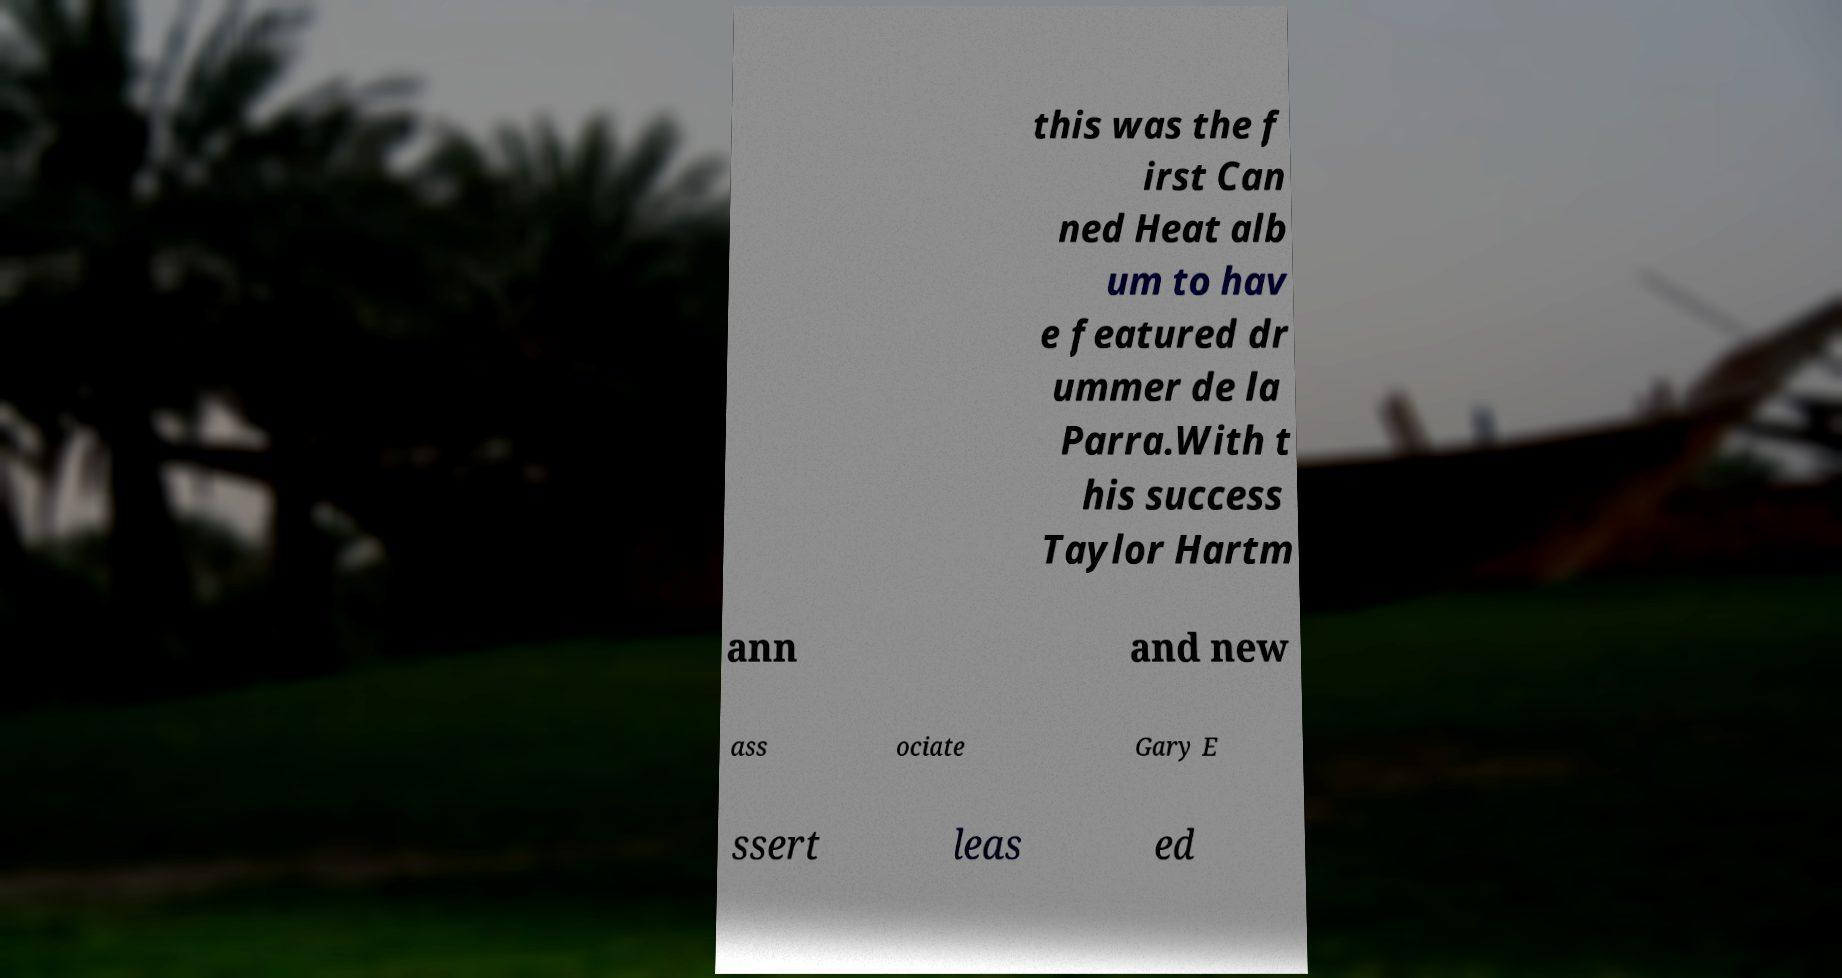Could you assist in decoding the text presented in this image and type it out clearly? this was the f irst Can ned Heat alb um to hav e featured dr ummer de la Parra.With t his success Taylor Hartm ann and new ass ociate Gary E ssert leas ed 